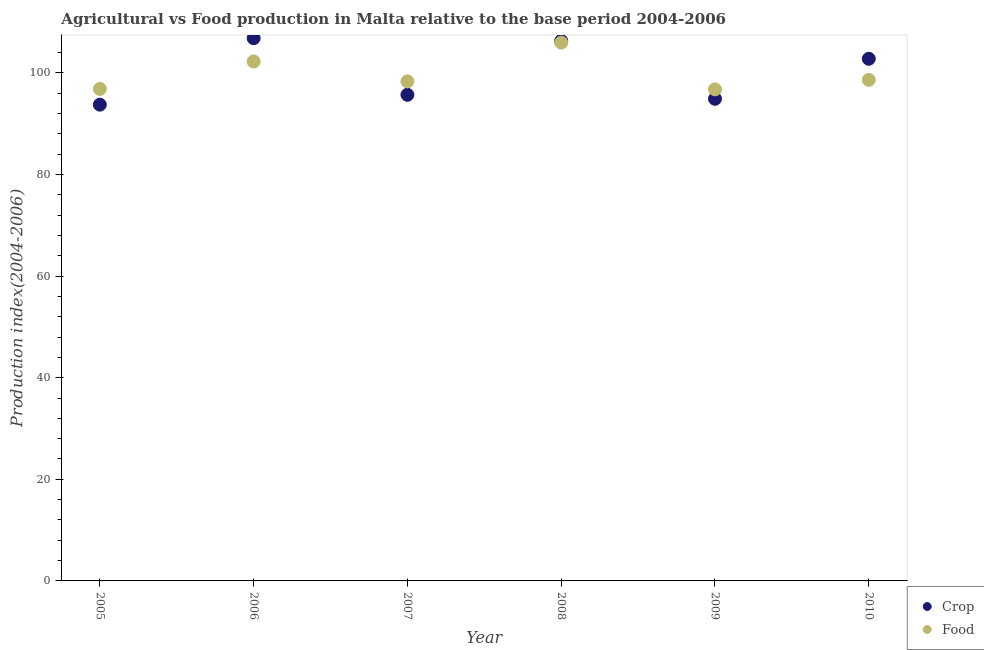How many different coloured dotlines are there?
Keep it short and to the point. 2. Is the number of dotlines equal to the number of legend labels?
Give a very brief answer. Yes. What is the crop production index in 2006?
Your answer should be very brief. 106.82. Across all years, what is the maximum crop production index?
Give a very brief answer. 106.82. Across all years, what is the minimum crop production index?
Offer a terse response. 93.74. In which year was the crop production index maximum?
Your answer should be very brief. 2006. In which year was the crop production index minimum?
Provide a short and direct response. 2005. What is the total food production index in the graph?
Ensure brevity in your answer.  598.74. What is the difference between the food production index in 2009 and that in 2010?
Provide a short and direct response. -1.87. What is the difference between the food production index in 2007 and the crop production index in 2006?
Offer a very short reply. -8.49. What is the average crop production index per year?
Your response must be concise. 100.03. In the year 2008, what is the difference between the food production index and crop production index?
Give a very brief answer. -0.34. In how many years, is the crop production index greater than 20?
Provide a succinct answer. 6. What is the ratio of the crop production index in 2005 to that in 2007?
Provide a succinct answer. 0.98. Is the food production index in 2005 less than that in 2006?
Your answer should be compact. Yes. Is the difference between the food production index in 2006 and 2007 greater than the difference between the crop production index in 2006 and 2007?
Your answer should be very brief. No. What is the difference between the highest and the second highest crop production index?
Keep it short and to the point. 0.52. What is the difference between the highest and the lowest food production index?
Make the answer very short. 9.21. In how many years, is the food production index greater than the average food production index taken over all years?
Your answer should be very brief. 2. Is the sum of the crop production index in 2006 and 2007 greater than the maximum food production index across all years?
Your answer should be compact. Yes. Does the crop production index monotonically increase over the years?
Give a very brief answer. No. Is the food production index strictly greater than the crop production index over the years?
Your answer should be compact. No. Is the crop production index strictly less than the food production index over the years?
Your response must be concise. No. How many dotlines are there?
Provide a short and direct response. 2. Does the graph contain grids?
Provide a short and direct response. No. How many legend labels are there?
Ensure brevity in your answer.  2. What is the title of the graph?
Your answer should be very brief. Agricultural vs Food production in Malta relative to the base period 2004-2006. What is the label or title of the Y-axis?
Offer a very short reply. Production index(2004-2006). What is the Production index(2004-2006) in Crop in 2005?
Ensure brevity in your answer.  93.74. What is the Production index(2004-2006) of Food in 2005?
Keep it short and to the point. 96.84. What is the Production index(2004-2006) of Crop in 2006?
Make the answer very short. 106.82. What is the Production index(2004-2006) of Food in 2006?
Your answer should be compact. 102.24. What is the Production index(2004-2006) of Crop in 2007?
Make the answer very short. 95.68. What is the Production index(2004-2006) in Food in 2007?
Give a very brief answer. 98.33. What is the Production index(2004-2006) of Crop in 2008?
Ensure brevity in your answer.  106.3. What is the Production index(2004-2006) in Food in 2008?
Make the answer very short. 105.96. What is the Production index(2004-2006) of Crop in 2009?
Provide a succinct answer. 94.89. What is the Production index(2004-2006) in Food in 2009?
Your answer should be very brief. 96.75. What is the Production index(2004-2006) in Crop in 2010?
Your response must be concise. 102.77. What is the Production index(2004-2006) in Food in 2010?
Make the answer very short. 98.62. Across all years, what is the maximum Production index(2004-2006) of Crop?
Give a very brief answer. 106.82. Across all years, what is the maximum Production index(2004-2006) of Food?
Make the answer very short. 105.96. Across all years, what is the minimum Production index(2004-2006) of Crop?
Your answer should be very brief. 93.74. Across all years, what is the minimum Production index(2004-2006) of Food?
Make the answer very short. 96.75. What is the total Production index(2004-2006) in Crop in the graph?
Keep it short and to the point. 600.2. What is the total Production index(2004-2006) in Food in the graph?
Provide a short and direct response. 598.74. What is the difference between the Production index(2004-2006) in Crop in 2005 and that in 2006?
Provide a succinct answer. -13.08. What is the difference between the Production index(2004-2006) in Crop in 2005 and that in 2007?
Provide a short and direct response. -1.94. What is the difference between the Production index(2004-2006) of Food in 2005 and that in 2007?
Provide a short and direct response. -1.49. What is the difference between the Production index(2004-2006) in Crop in 2005 and that in 2008?
Provide a succinct answer. -12.56. What is the difference between the Production index(2004-2006) in Food in 2005 and that in 2008?
Provide a succinct answer. -9.12. What is the difference between the Production index(2004-2006) of Crop in 2005 and that in 2009?
Your response must be concise. -1.15. What is the difference between the Production index(2004-2006) of Food in 2005 and that in 2009?
Your answer should be very brief. 0.09. What is the difference between the Production index(2004-2006) in Crop in 2005 and that in 2010?
Ensure brevity in your answer.  -9.03. What is the difference between the Production index(2004-2006) in Food in 2005 and that in 2010?
Ensure brevity in your answer.  -1.78. What is the difference between the Production index(2004-2006) of Crop in 2006 and that in 2007?
Make the answer very short. 11.14. What is the difference between the Production index(2004-2006) in Food in 2006 and that in 2007?
Your answer should be compact. 3.91. What is the difference between the Production index(2004-2006) of Crop in 2006 and that in 2008?
Keep it short and to the point. 0.52. What is the difference between the Production index(2004-2006) in Food in 2006 and that in 2008?
Give a very brief answer. -3.72. What is the difference between the Production index(2004-2006) of Crop in 2006 and that in 2009?
Provide a succinct answer. 11.93. What is the difference between the Production index(2004-2006) in Food in 2006 and that in 2009?
Offer a terse response. 5.49. What is the difference between the Production index(2004-2006) in Crop in 2006 and that in 2010?
Your answer should be compact. 4.05. What is the difference between the Production index(2004-2006) in Food in 2006 and that in 2010?
Make the answer very short. 3.62. What is the difference between the Production index(2004-2006) of Crop in 2007 and that in 2008?
Provide a succinct answer. -10.62. What is the difference between the Production index(2004-2006) of Food in 2007 and that in 2008?
Offer a very short reply. -7.63. What is the difference between the Production index(2004-2006) of Crop in 2007 and that in 2009?
Your response must be concise. 0.79. What is the difference between the Production index(2004-2006) of Food in 2007 and that in 2009?
Offer a very short reply. 1.58. What is the difference between the Production index(2004-2006) of Crop in 2007 and that in 2010?
Offer a very short reply. -7.09. What is the difference between the Production index(2004-2006) in Food in 2007 and that in 2010?
Keep it short and to the point. -0.29. What is the difference between the Production index(2004-2006) in Crop in 2008 and that in 2009?
Your answer should be very brief. 11.41. What is the difference between the Production index(2004-2006) in Food in 2008 and that in 2009?
Your answer should be very brief. 9.21. What is the difference between the Production index(2004-2006) of Crop in 2008 and that in 2010?
Provide a succinct answer. 3.53. What is the difference between the Production index(2004-2006) in Food in 2008 and that in 2010?
Provide a succinct answer. 7.34. What is the difference between the Production index(2004-2006) in Crop in 2009 and that in 2010?
Make the answer very short. -7.88. What is the difference between the Production index(2004-2006) in Food in 2009 and that in 2010?
Your response must be concise. -1.87. What is the difference between the Production index(2004-2006) of Crop in 2005 and the Production index(2004-2006) of Food in 2006?
Keep it short and to the point. -8.5. What is the difference between the Production index(2004-2006) in Crop in 2005 and the Production index(2004-2006) in Food in 2007?
Keep it short and to the point. -4.59. What is the difference between the Production index(2004-2006) in Crop in 2005 and the Production index(2004-2006) in Food in 2008?
Your answer should be very brief. -12.22. What is the difference between the Production index(2004-2006) in Crop in 2005 and the Production index(2004-2006) in Food in 2009?
Offer a very short reply. -3.01. What is the difference between the Production index(2004-2006) of Crop in 2005 and the Production index(2004-2006) of Food in 2010?
Offer a very short reply. -4.88. What is the difference between the Production index(2004-2006) of Crop in 2006 and the Production index(2004-2006) of Food in 2007?
Provide a succinct answer. 8.49. What is the difference between the Production index(2004-2006) of Crop in 2006 and the Production index(2004-2006) of Food in 2008?
Your response must be concise. 0.86. What is the difference between the Production index(2004-2006) in Crop in 2006 and the Production index(2004-2006) in Food in 2009?
Offer a very short reply. 10.07. What is the difference between the Production index(2004-2006) in Crop in 2006 and the Production index(2004-2006) in Food in 2010?
Offer a very short reply. 8.2. What is the difference between the Production index(2004-2006) of Crop in 2007 and the Production index(2004-2006) of Food in 2008?
Keep it short and to the point. -10.28. What is the difference between the Production index(2004-2006) in Crop in 2007 and the Production index(2004-2006) in Food in 2009?
Make the answer very short. -1.07. What is the difference between the Production index(2004-2006) of Crop in 2007 and the Production index(2004-2006) of Food in 2010?
Your answer should be compact. -2.94. What is the difference between the Production index(2004-2006) of Crop in 2008 and the Production index(2004-2006) of Food in 2009?
Keep it short and to the point. 9.55. What is the difference between the Production index(2004-2006) in Crop in 2008 and the Production index(2004-2006) in Food in 2010?
Offer a very short reply. 7.68. What is the difference between the Production index(2004-2006) in Crop in 2009 and the Production index(2004-2006) in Food in 2010?
Provide a succinct answer. -3.73. What is the average Production index(2004-2006) in Crop per year?
Give a very brief answer. 100.03. What is the average Production index(2004-2006) in Food per year?
Offer a very short reply. 99.79. In the year 2006, what is the difference between the Production index(2004-2006) of Crop and Production index(2004-2006) of Food?
Ensure brevity in your answer.  4.58. In the year 2007, what is the difference between the Production index(2004-2006) of Crop and Production index(2004-2006) of Food?
Give a very brief answer. -2.65. In the year 2008, what is the difference between the Production index(2004-2006) in Crop and Production index(2004-2006) in Food?
Give a very brief answer. 0.34. In the year 2009, what is the difference between the Production index(2004-2006) of Crop and Production index(2004-2006) of Food?
Offer a very short reply. -1.86. In the year 2010, what is the difference between the Production index(2004-2006) of Crop and Production index(2004-2006) of Food?
Offer a terse response. 4.15. What is the ratio of the Production index(2004-2006) in Crop in 2005 to that in 2006?
Ensure brevity in your answer.  0.88. What is the ratio of the Production index(2004-2006) of Food in 2005 to that in 2006?
Provide a short and direct response. 0.95. What is the ratio of the Production index(2004-2006) in Crop in 2005 to that in 2007?
Offer a terse response. 0.98. What is the ratio of the Production index(2004-2006) of Crop in 2005 to that in 2008?
Make the answer very short. 0.88. What is the ratio of the Production index(2004-2006) of Food in 2005 to that in 2008?
Provide a short and direct response. 0.91. What is the ratio of the Production index(2004-2006) of Crop in 2005 to that in 2009?
Keep it short and to the point. 0.99. What is the ratio of the Production index(2004-2006) in Food in 2005 to that in 2009?
Make the answer very short. 1. What is the ratio of the Production index(2004-2006) in Crop in 2005 to that in 2010?
Provide a succinct answer. 0.91. What is the ratio of the Production index(2004-2006) in Food in 2005 to that in 2010?
Your answer should be compact. 0.98. What is the ratio of the Production index(2004-2006) of Crop in 2006 to that in 2007?
Provide a succinct answer. 1.12. What is the ratio of the Production index(2004-2006) in Food in 2006 to that in 2007?
Your response must be concise. 1.04. What is the ratio of the Production index(2004-2006) in Food in 2006 to that in 2008?
Give a very brief answer. 0.96. What is the ratio of the Production index(2004-2006) of Crop in 2006 to that in 2009?
Provide a succinct answer. 1.13. What is the ratio of the Production index(2004-2006) of Food in 2006 to that in 2009?
Provide a short and direct response. 1.06. What is the ratio of the Production index(2004-2006) in Crop in 2006 to that in 2010?
Your answer should be very brief. 1.04. What is the ratio of the Production index(2004-2006) of Food in 2006 to that in 2010?
Your response must be concise. 1.04. What is the ratio of the Production index(2004-2006) of Crop in 2007 to that in 2008?
Offer a terse response. 0.9. What is the ratio of the Production index(2004-2006) of Food in 2007 to that in 2008?
Offer a terse response. 0.93. What is the ratio of the Production index(2004-2006) of Crop in 2007 to that in 2009?
Your response must be concise. 1.01. What is the ratio of the Production index(2004-2006) in Food in 2007 to that in 2009?
Provide a succinct answer. 1.02. What is the ratio of the Production index(2004-2006) in Food in 2007 to that in 2010?
Give a very brief answer. 1. What is the ratio of the Production index(2004-2006) of Crop in 2008 to that in 2009?
Ensure brevity in your answer.  1.12. What is the ratio of the Production index(2004-2006) in Food in 2008 to that in 2009?
Provide a succinct answer. 1.1. What is the ratio of the Production index(2004-2006) in Crop in 2008 to that in 2010?
Ensure brevity in your answer.  1.03. What is the ratio of the Production index(2004-2006) of Food in 2008 to that in 2010?
Your response must be concise. 1.07. What is the ratio of the Production index(2004-2006) in Crop in 2009 to that in 2010?
Offer a very short reply. 0.92. What is the difference between the highest and the second highest Production index(2004-2006) of Crop?
Offer a terse response. 0.52. What is the difference between the highest and the second highest Production index(2004-2006) in Food?
Your response must be concise. 3.72. What is the difference between the highest and the lowest Production index(2004-2006) in Crop?
Offer a very short reply. 13.08. What is the difference between the highest and the lowest Production index(2004-2006) in Food?
Your response must be concise. 9.21. 